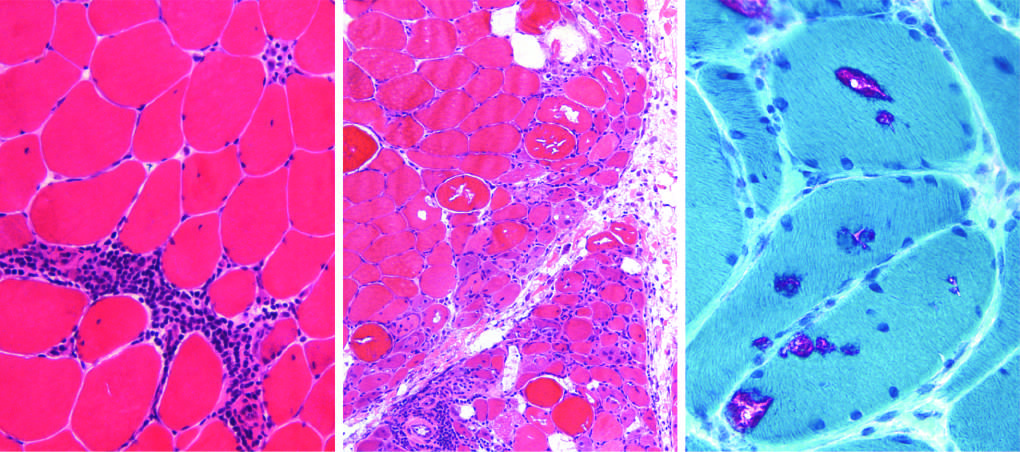what shows prominent perifascicular and paraseptal atrophy?
Answer the question using a single word or phrase. Dermatomyositis 